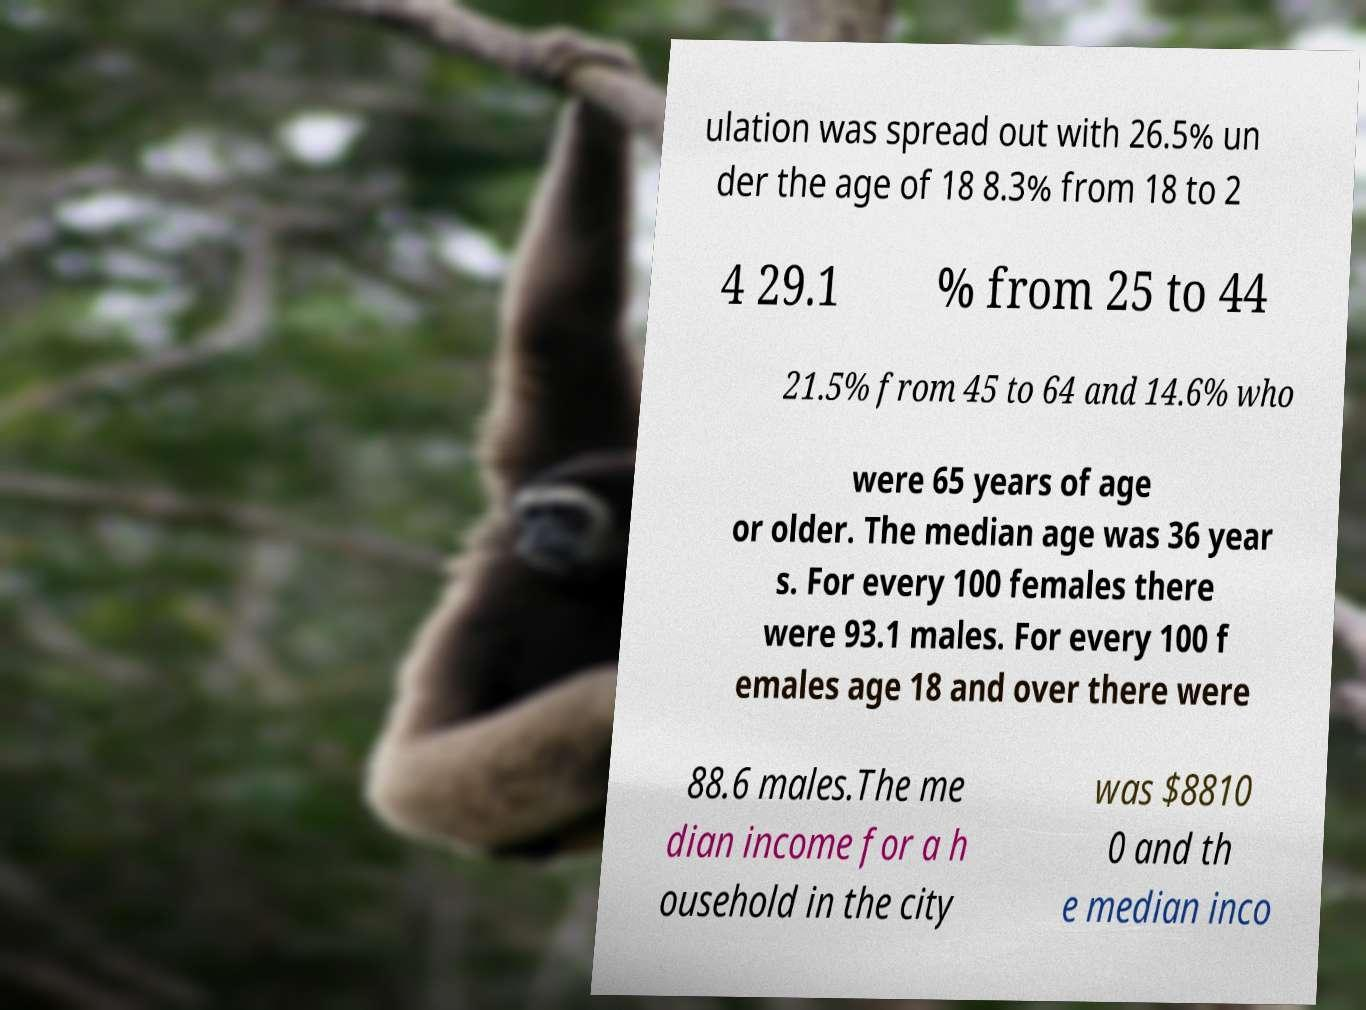Could you assist in decoding the text presented in this image and type it out clearly? ulation was spread out with 26.5% un der the age of 18 8.3% from 18 to 2 4 29.1 % from 25 to 44 21.5% from 45 to 64 and 14.6% who were 65 years of age or older. The median age was 36 year s. For every 100 females there were 93.1 males. For every 100 f emales age 18 and over there were 88.6 males.The me dian income for a h ousehold in the city was $8810 0 and th e median inco 